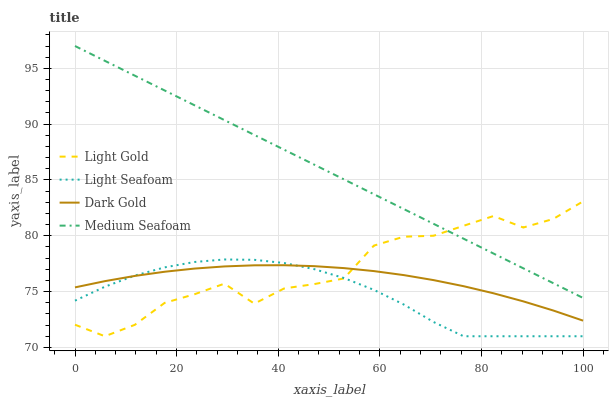Does Light Seafoam have the minimum area under the curve?
Answer yes or no. Yes. Does Medium Seafoam have the maximum area under the curve?
Answer yes or no. Yes. Does Light Gold have the minimum area under the curve?
Answer yes or no. No. Does Light Gold have the maximum area under the curve?
Answer yes or no. No. Is Medium Seafoam the smoothest?
Answer yes or no. Yes. Is Light Gold the roughest?
Answer yes or no. Yes. Is Light Gold the smoothest?
Answer yes or no. No. Is Medium Seafoam the roughest?
Answer yes or no. No. Does Medium Seafoam have the lowest value?
Answer yes or no. No. Does Medium Seafoam have the highest value?
Answer yes or no. Yes. Does Light Gold have the highest value?
Answer yes or no. No. Is Light Seafoam less than Medium Seafoam?
Answer yes or no. Yes. Is Medium Seafoam greater than Light Seafoam?
Answer yes or no. Yes. Does Light Seafoam intersect Light Gold?
Answer yes or no. Yes. Is Light Seafoam less than Light Gold?
Answer yes or no. No. Is Light Seafoam greater than Light Gold?
Answer yes or no. No. Does Light Seafoam intersect Medium Seafoam?
Answer yes or no. No. 